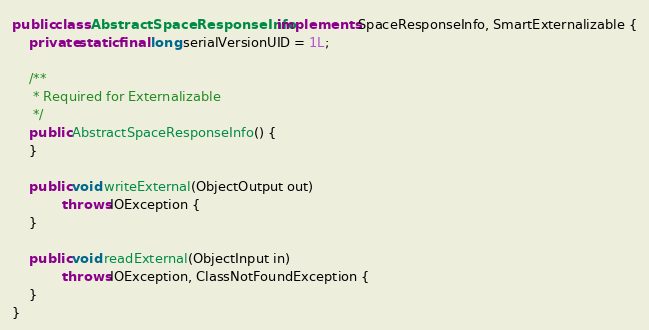<code> <loc_0><loc_0><loc_500><loc_500><_Java_>public class AbstractSpaceResponseInfo implements SpaceResponseInfo, SmartExternalizable {
    private static final long serialVersionUID = 1L;

    /**
     * Required for Externalizable
     */
    public AbstractSpaceResponseInfo() {
    }

    public void writeExternal(ObjectOutput out)
            throws IOException {
    }

    public void readExternal(ObjectInput in)
            throws IOException, ClassNotFoundException {
    }
}
</code> 